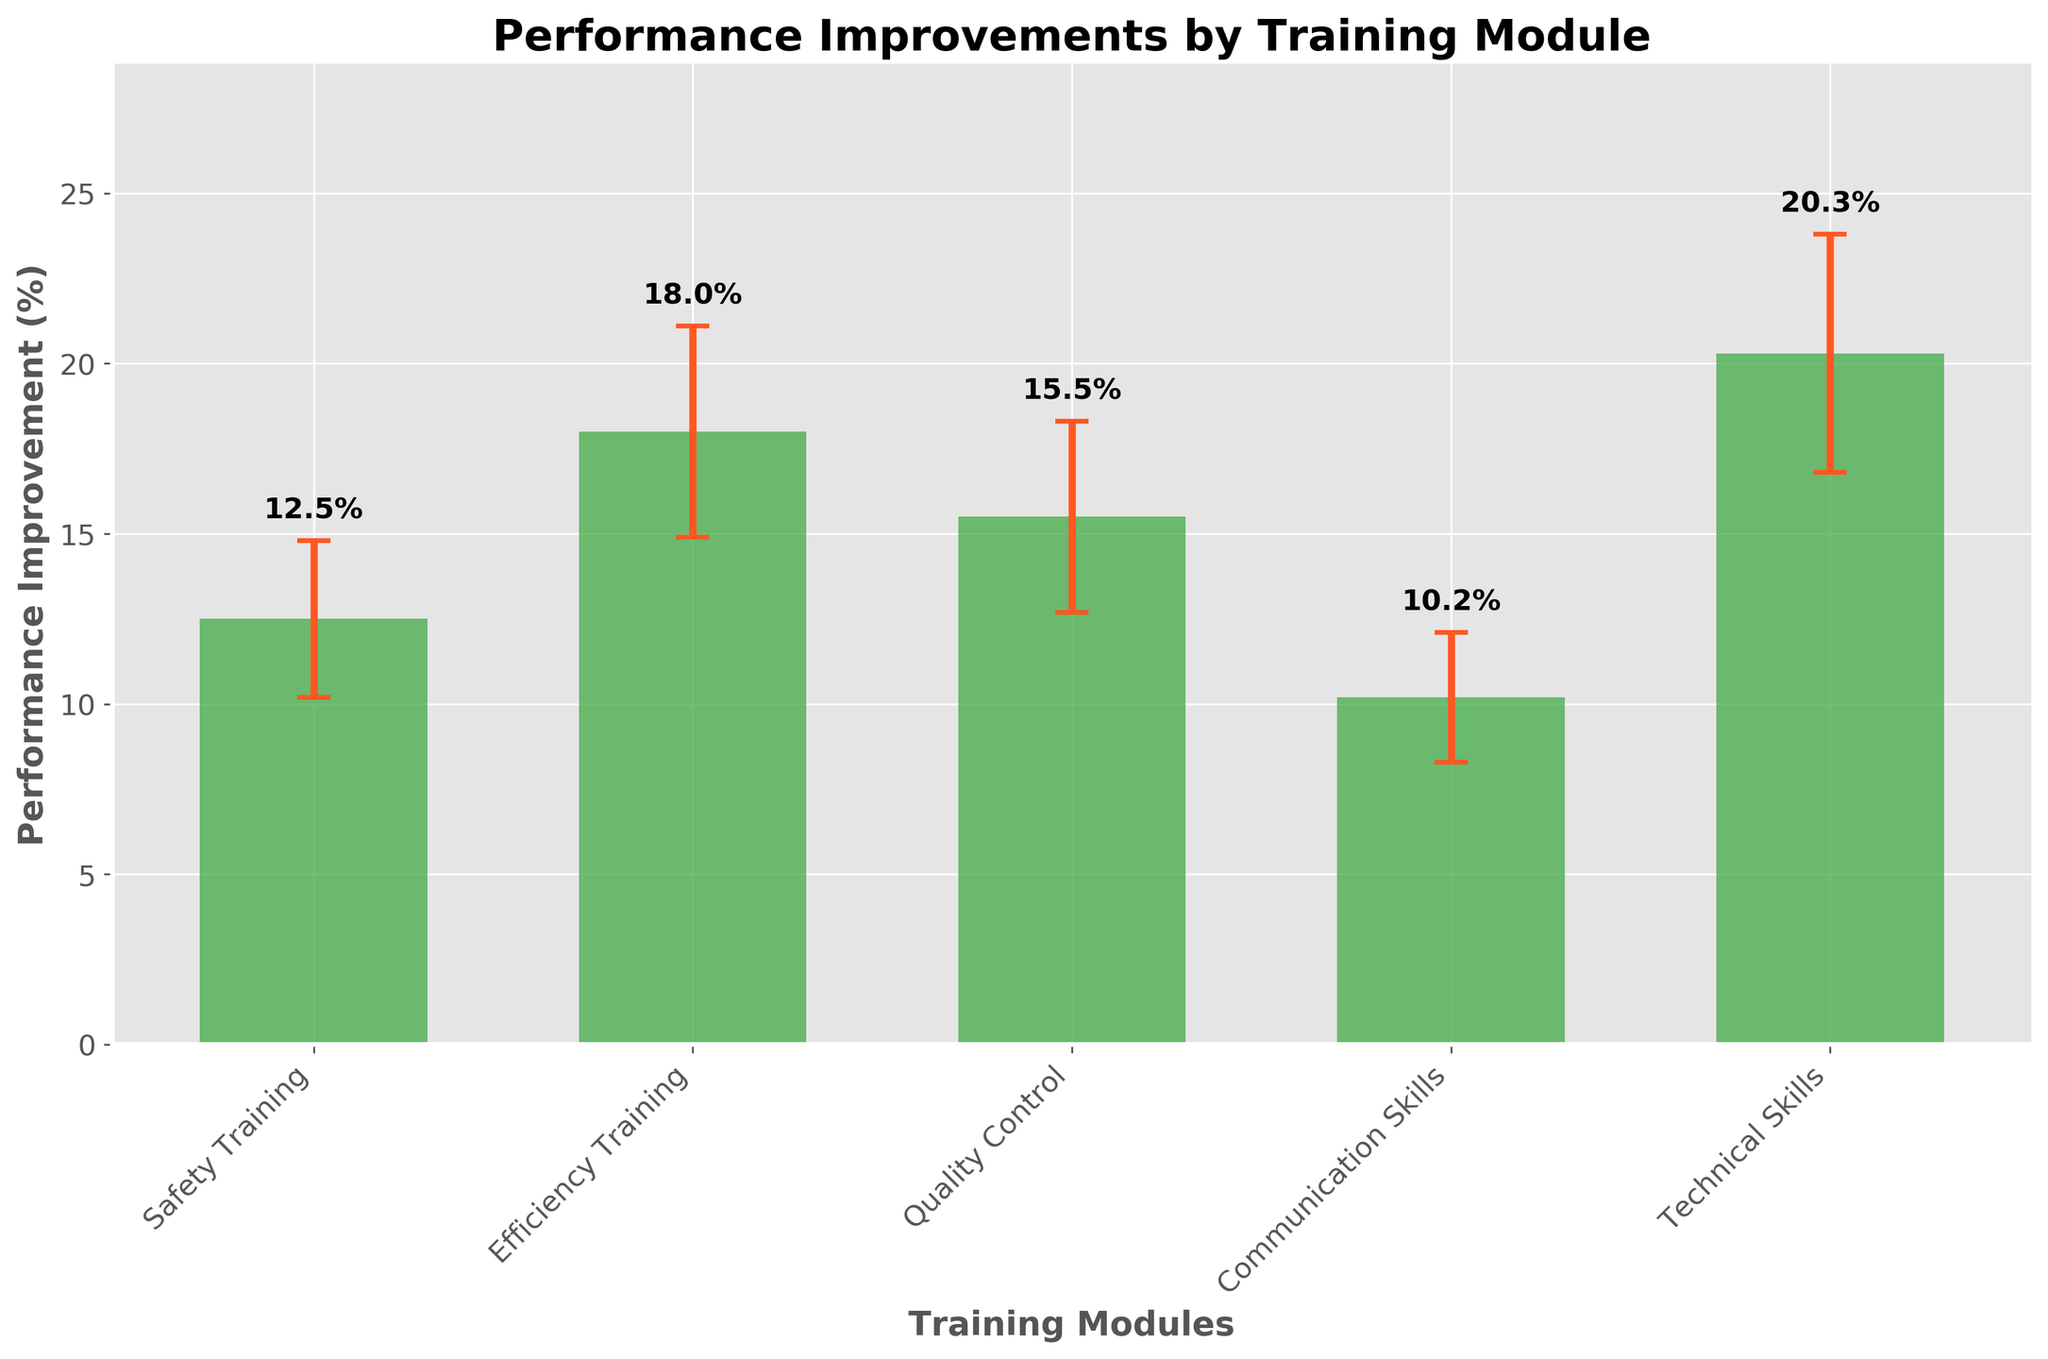What is the title of the figure? The title of the figure is located at the top center of the plot. It visually represents the main subject of the chart.
Answer: Performance Improvements by Training Module How many training modules are represented in the figure? You can count the number of distinct bars on the x-axis to determine the number of training modules.
Answer: 5 Which training module has the highest mean performance improvement? By comparing the heights of all bars, the tallest bar indicates the highest mean performance improvement.
Answer: Technical Skills What is the mean performance improvement for Communication Skills training? Locate the bar corresponding to Communication Skills and look at the label near its top or use the y-axis scaling.
Answer: 10.2% What is the difference in mean performance improvement between Technical Skills and Safety Training? Subtract the mean improvement of Safety Training from the mean improvement of Technical Skills: 20.3 - 12.5.
Answer: 7.8% Which training module has the smallest error bar? Compare the lengths of the error bars across all modules; the shortest error bar represents the smallest standard deviation.
Answer: Communication Skills What is the average mean performance improvement across all training modules? Add up the mean improvements (12.5 + 18.0 + 15.5 + 10.2 + 20.3) and divide by the number of modules (5).
Answer: 15.3% Between Efficiency Training and Quality Control, which has a higher standard deviation? Compare the lengths of the error bars for Efficiency Training and Quality Control and check the labels near the bars.
Answer: Efficiency Training What is the range of mean performance improvements (from lowest to highest) shown in the chart? Identify the lowest mean improvement (10.2% for Communication Skills) and the highest mean improvement (20.3% for Technical Skills) and calculate the range (20.3 - 10.2).
Answer: 10.1% If you were to add the smallest and largest mean performance improvements, what would that value be? Sum the smallest mean improvement (10.2% for Communication Skills) and the largest mean improvement (20.3% for Technical Skills).
Answer: 30.5% 